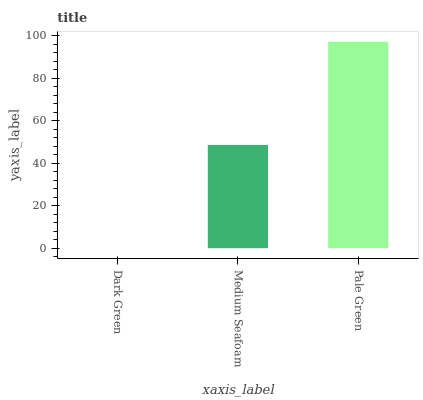Is Dark Green the minimum?
Answer yes or no. Yes. Is Pale Green the maximum?
Answer yes or no. Yes. Is Medium Seafoam the minimum?
Answer yes or no. No. Is Medium Seafoam the maximum?
Answer yes or no. No. Is Medium Seafoam greater than Dark Green?
Answer yes or no. Yes. Is Dark Green less than Medium Seafoam?
Answer yes or no. Yes. Is Dark Green greater than Medium Seafoam?
Answer yes or no. No. Is Medium Seafoam less than Dark Green?
Answer yes or no. No. Is Medium Seafoam the high median?
Answer yes or no. Yes. Is Medium Seafoam the low median?
Answer yes or no. Yes. Is Dark Green the high median?
Answer yes or no. No. Is Pale Green the low median?
Answer yes or no. No. 